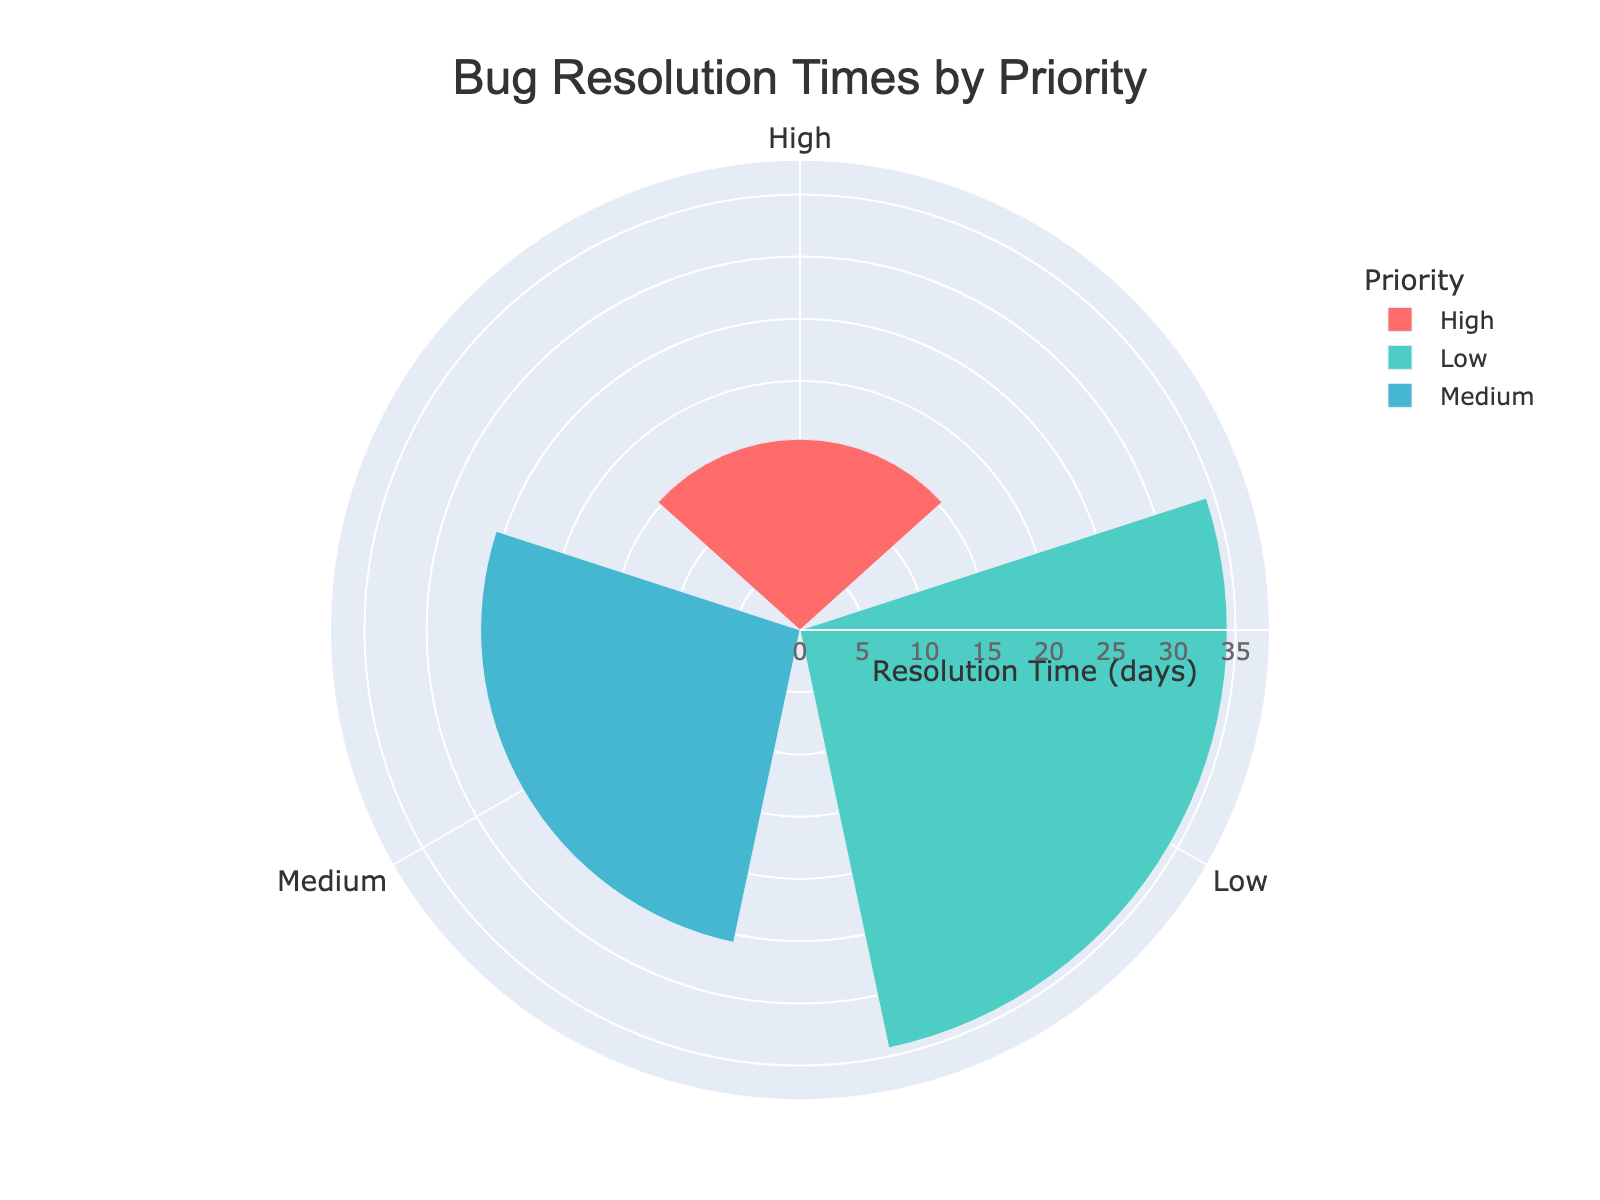what is the title of the figure? The title of the figure is displayed at the top, stating the subject of the plot. It usually informs the viewer about the main focus of the visualization. From the given data, the title is clear and situated in the figure.
Answer: "Bug Resolution Times by Priority" Which priority level has the highest average resolution time? Refer to the radial data displayed on the rose chart. The highest average resolution time is represented by the longest bar. Compare the lengths for High, Medium, and Low priorities.
Answer: Low What is the average resolution time for Medium priority bugs? Check the Medium priority segment of the rose chart. The chart shows the average resolution time directly as part of the radial value.
Answer: 25 days Compare the bug count between High priority and Low priority levels. Add the total bugs for each priority level from the hover text: High (Authentication: 5, Database: 3, Frontend: 8) and Low (Authentication: 7, Database: 4, Frontend: 15). High has 5 + 3 + 8 = 16 bugs, Low has 7 + 4 + 15 = 26 bugs.
Answer: Low has more bugs Which priority level resolves bugs faster on average? Compare the average resolution times for High, Medium, and Low priorities depicted radially on the rose chart. The shortest bar indicates the fastest average resolution time.
Answer: High How does the resolution time for High priority bugs compare to Medium priority bugs? From the chart, High priority has an average resolution time around 15.3 days, whereas Medium is approximately 25 days. Subtracting the values gives the difference.
Answer: High is about 9.7 days faster What's the sum of the total bugs across all priorities? Sum the total bugs for each priority: High (16 bugs), Medium (27 bugs), Low (26 bugs). Adding them yields 16 + 27 + 26.
Answer: 69 bugs Which group has the second-highest average resolution time? Upon examining the rose chart, identify the priority groups in descending order of resolution times. The second-longest bar corresponds to this group.
Answer: Medium What color represents the High priority group? Colors are assigned to groups on the chart. Look for the color corresponding to the High priority label.
Answer: Red Is there a visible legend in the plot, and what does it denote? The legend usually appears on the side of the plot, denoting different groups and the colors representing them. Check if the legend exists and lists all priority levels.
Answer: Yes, it shows two priority levels 